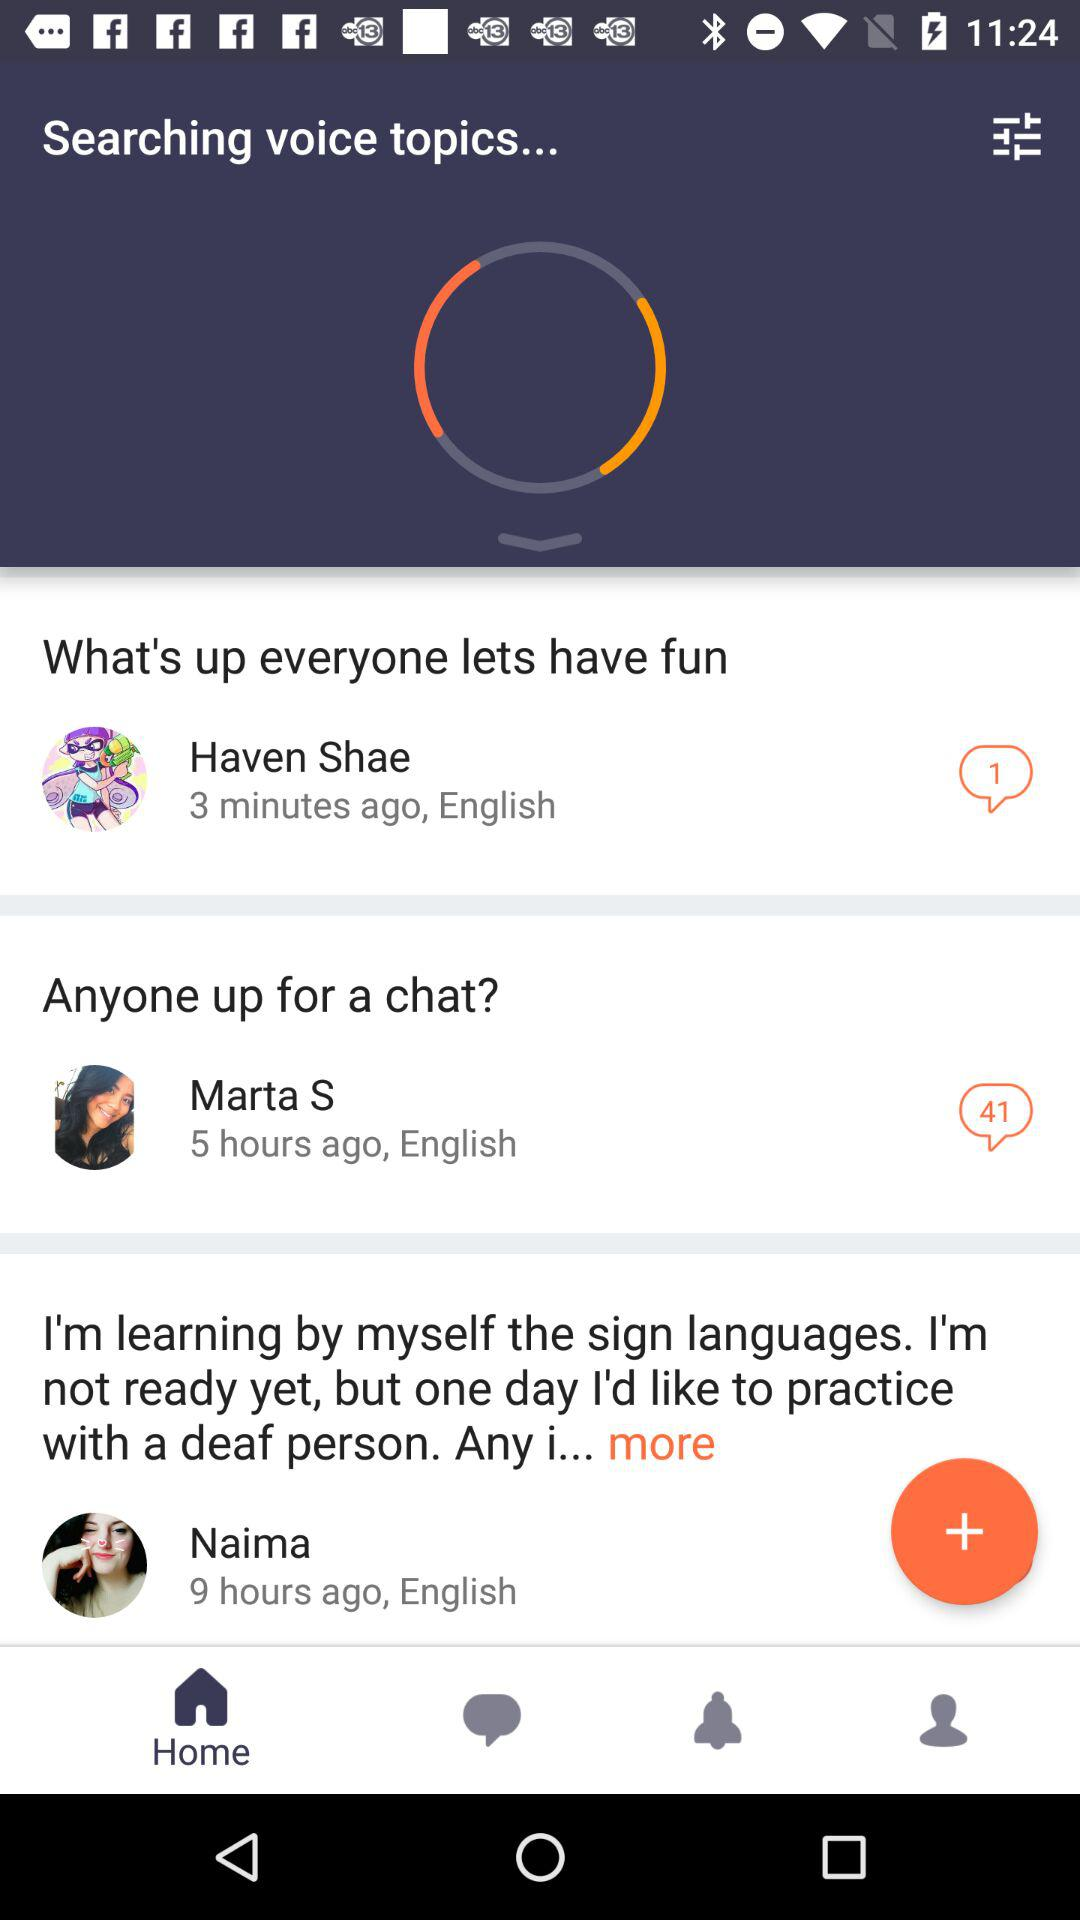How many chats are there for Marta S? There are 41 chats. 